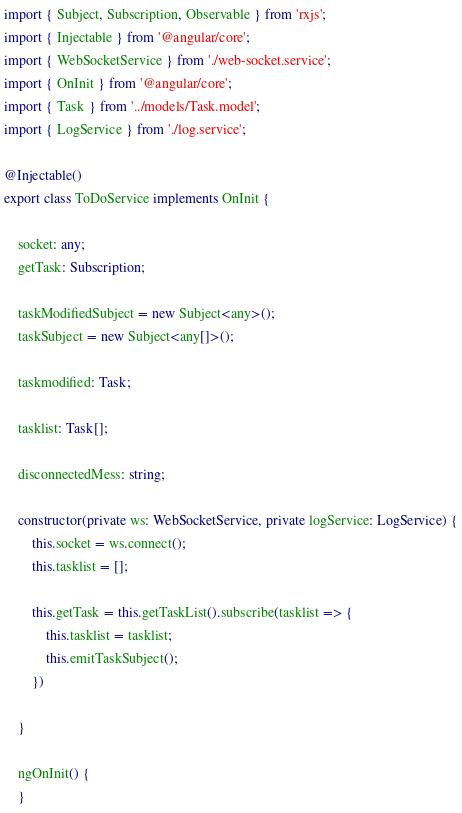Convert code to text. <code><loc_0><loc_0><loc_500><loc_500><_TypeScript_>import { Subject, Subscription, Observable } from 'rxjs';
import { Injectable } from '@angular/core';
import { WebSocketService } from './web-socket.service';
import { OnInit } from '@angular/core';
import { Task } from '../models/Task.model';
import { LogService } from './log.service';

@Injectable()
export class ToDoService implements OnInit {

    socket: any;
    getTask: Subscription;

    taskModifiedSubject = new Subject<any>();
    taskSubject = new Subject<any[]>();

    taskmodified: Task;

    tasklist: Task[];

    disconnectedMess: string;

    constructor(private ws: WebSocketService, private logService: LogService) {
        this.socket = ws.connect();
        this.tasklist = [];

        this.getTask = this.getTaskList().subscribe(tasklist => {
            this.tasklist = tasklist;
            this.emitTaskSubject();
        })

    }

    ngOnInit() {
    }
</code> 